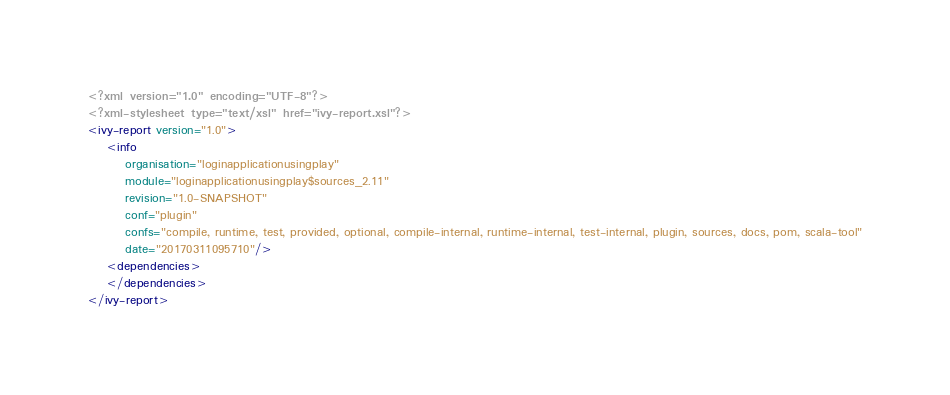<code> <loc_0><loc_0><loc_500><loc_500><_XML_><?xml version="1.0" encoding="UTF-8"?>
<?xml-stylesheet type="text/xsl" href="ivy-report.xsl"?>
<ivy-report version="1.0">
	<info
		organisation="loginapplicationusingplay"
		module="loginapplicationusingplay$sources_2.11"
		revision="1.0-SNAPSHOT"
		conf="plugin"
		confs="compile, runtime, test, provided, optional, compile-internal, runtime-internal, test-internal, plugin, sources, docs, pom, scala-tool"
		date="20170311095710"/>
	<dependencies>
	</dependencies>
</ivy-report>
</code> 